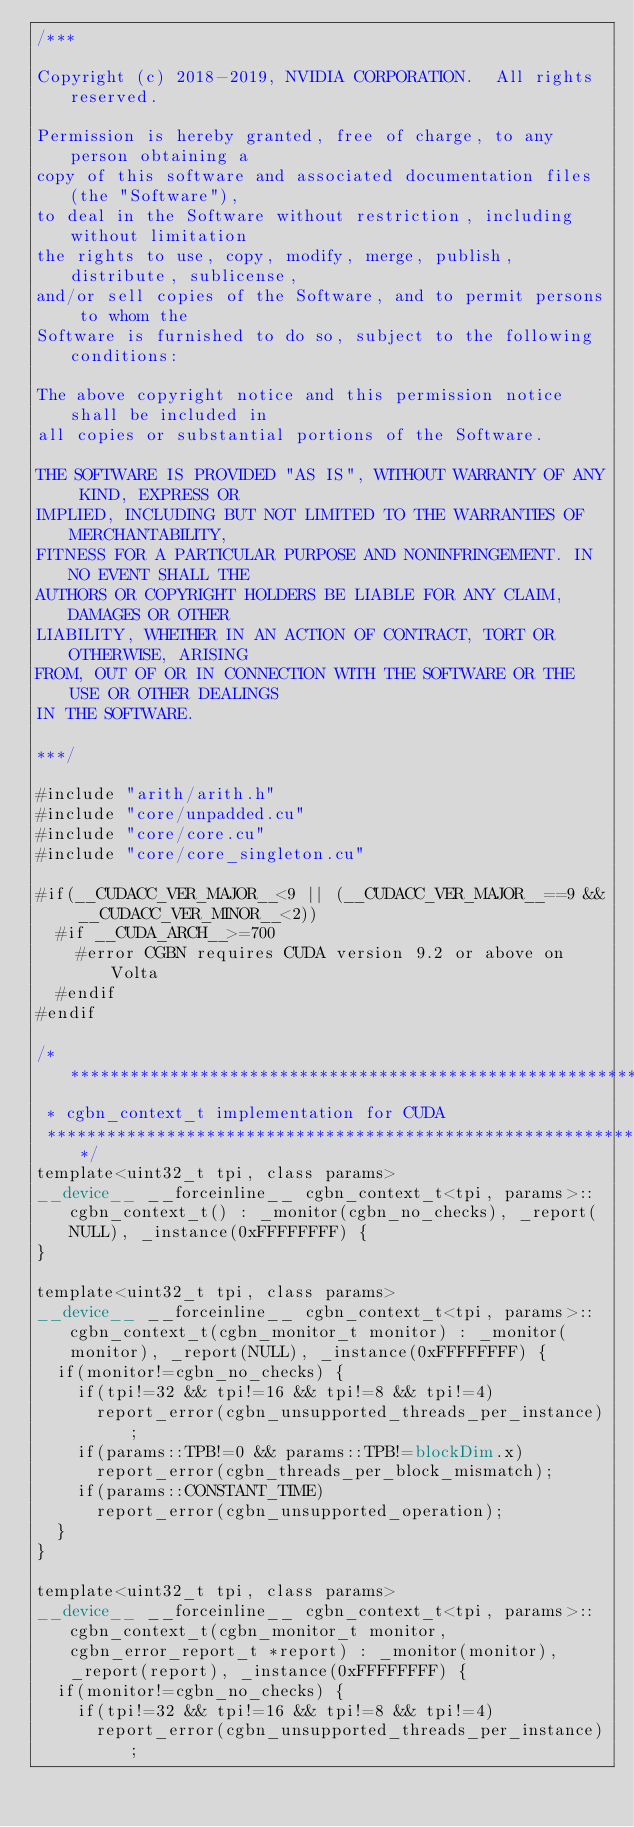<code> <loc_0><loc_0><loc_500><loc_500><_Cuda_>/***

Copyright (c) 2018-2019, NVIDIA CORPORATION.  All rights reserved.

Permission is hereby granted, free of charge, to any person obtaining a
copy of this software and associated documentation files (the "Software"),
to deal in the Software without restriction, including without limitation
the rights to use, copy, modify, merge, publish, distribute, sublicense,
and/or sell copies of the Software, and to permit persons to whom the
Software is furnished to do so, subject to the following conditions:

The above copyright notice and this permission notice shall be included in
all copies or substantial portions of the Software.

THE SOFTWARE IS PROVIDED "AS IS", WITHOUT WARRANTY OF ANY KIND, EXPRESS OR
IMPLIED, INCLUDING BUT NOT LIMITED TO THE WARRANTIES OF MERCHANTABILITY,
FITNESS FOR A PARTICULAR PURPOSE AND NONINFRINGEMENT. IN NO EVENT SHALL THE
AUTHORS OR COPYRIGHT HOLDERS BE LIABLE FOR ANY CLAIM, DAMAGES OR OTHER
LIABILITY, WHETHER IN AN ACTION OF CONTRACT, TORT OR OTHERWISE, ARISING
FROM, OUT OF OR IN CONNECTION WITH THE SOFTWARE OR THE USE OR OTHER DEALINGS
IN THE SOFTWARE.

***/

#include "arith/arith.h"
#include "core/unpadded.cu"
#include "core/core.cu"
#include "core/core_singleton.cu"

#if(__CUDACC_VER_MAJOR__<9 || (__CUDACC_VER_MAJOR__==9 && __CUDACC_VER_MINOR__<2))
  #if __CUDA_ARCH__>=700
    #error CGBN requires CUDA version 9.2 or above on Volta
  #endif
#endif

/****************************************************************************************************************
 * cgbn_context_t implementation for CUDA
 ****************************************************************************************************************/
template<uint32_t tpi, class params>
__device__ __forceinline__ cgbn_context_t<tpi, params>::cgbn_context_t() : _monitor(cgbn_no_checks), _report(NULL), _instance(0xFFFFFFFF) {
}

template<uint32_t tpi, class params>
__device__ __forceinline__ cgbn_context_t<tpi, params>::cgbn_context_t(cgbn_monitor_t monitor) : _monitor(monitor), _report(NULL), _instance(0xFFFFFFFF) {
  if(monitor!=cgbn_no_checks) {
    if(tpi!=32 && tpi!=16 && tpi!=8 && tpi!=4)
      report_error(cgbn_unsupported_threads_per_instance);
    if(params::TPB!=0 && params::TPB!=blockDim.x)
      report_error(cgbn_threads_per_block_mismatch);
    if(params::CONSTANT_TIME)
      report_error(cgbn_unsupported_operation);
  }
}

template<uint32_t tpi, class params>
__device__ __forceinline__ cgbn_context_t<tpi, params>::cgbn_context_t(cgbn_monitor_t monitor, cgbn_error_report_t *report) : _monitor(monitor), _report(report), _instance(0xFFFFFFFF) {
  if(monitor!=cgbn_no_checks) {
    if(tpi!=32 && tpi!=16 && tpi!=8 && tpi!=4)
      report_error(cgbn_unsupported_threads_per_instance);</code> 